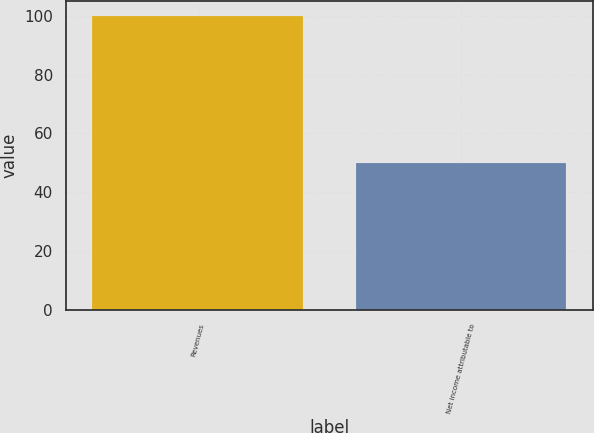<chart> <loc_0><loc_0><loc_500><loc_500><bar_chart><fcel>Revenues<fcel>Net income attributable to<nl><fcel>100<fcel>50<nl></chart> 